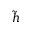Convert formula to latex. <formula><loc_0><loc_0><loc_500><loc_500>\tilde { h }</formula> 